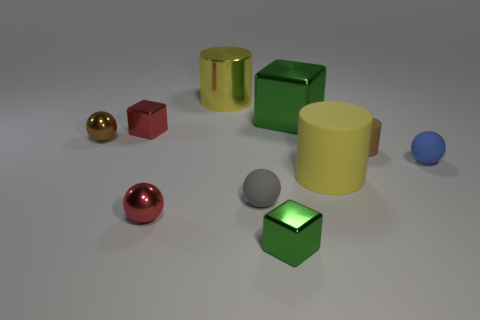There is a big yellow object that is the same material as the big block; what is its shape?
Your answer should be very brief. Cylinder. How many small balls are on the left side of the yellow metal thing and in front of the big matte thing?
Ensure brevity in your answer.  1. There is a small green block; are there any brown spheres to the left of it?
Make the answer very short. Yes. Do the large metal object that is behind the large block and the red metal object in front of the gray object have the same shape?
Keep it short and to the point. No. How many things are tiny brown spheres or cubes that are to the right of the gray rubber ball?
Give a very brief answer. 3. What number of other things are the same shape as the tiny blue thing?
Provide a succinct answer. 3. Is the yellow cylinder to the right of the big block made of the same material as the gray thing?
Offer a terse response. Yes. What number of objects are either green rubber balls or matte spheres?
Offer a very short reply. 2. What is the size of the brown matte thing that is the same shape as the yellow matte thing?
Provide a short and direct response. Small. The blue rubber thing is what size?
Your answer should be very brief. Small. 